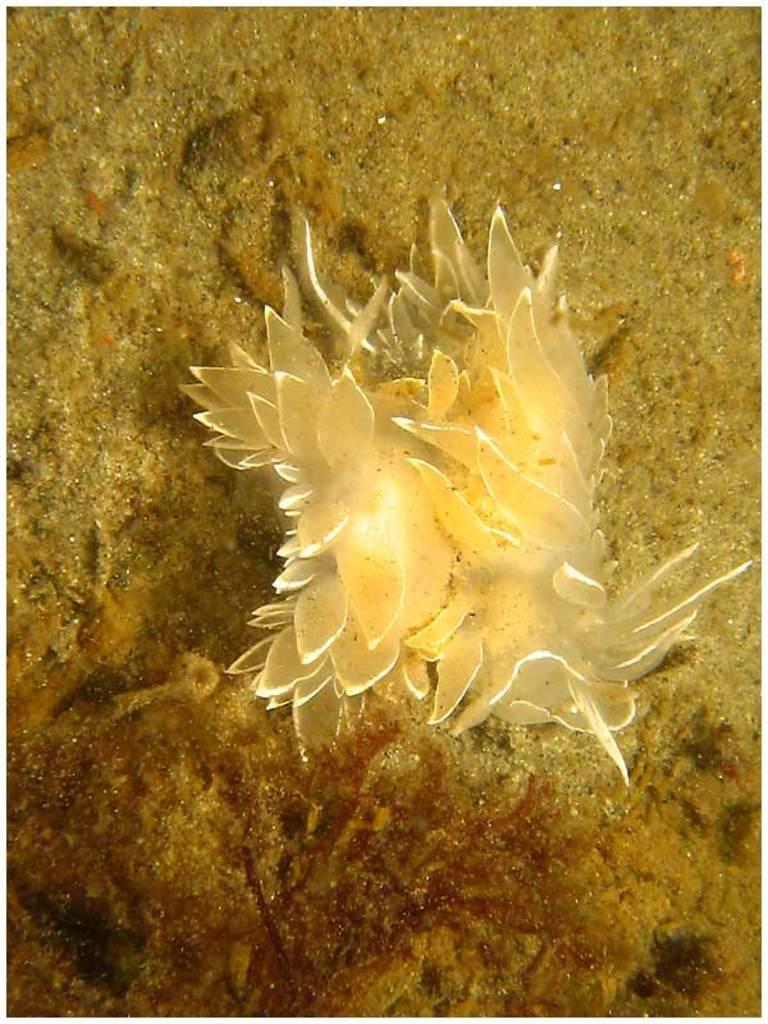What type of plants are in the image? There are water plants in the image. What type of terrain is visible in the image? There is sand visible in the image. Where is the cannon located in the image? There is no cannon present in the image. What type of clothing is visible in the image? There is no clothing visible in the image. What type of bird is present in the image? There is no bird present in the image. 